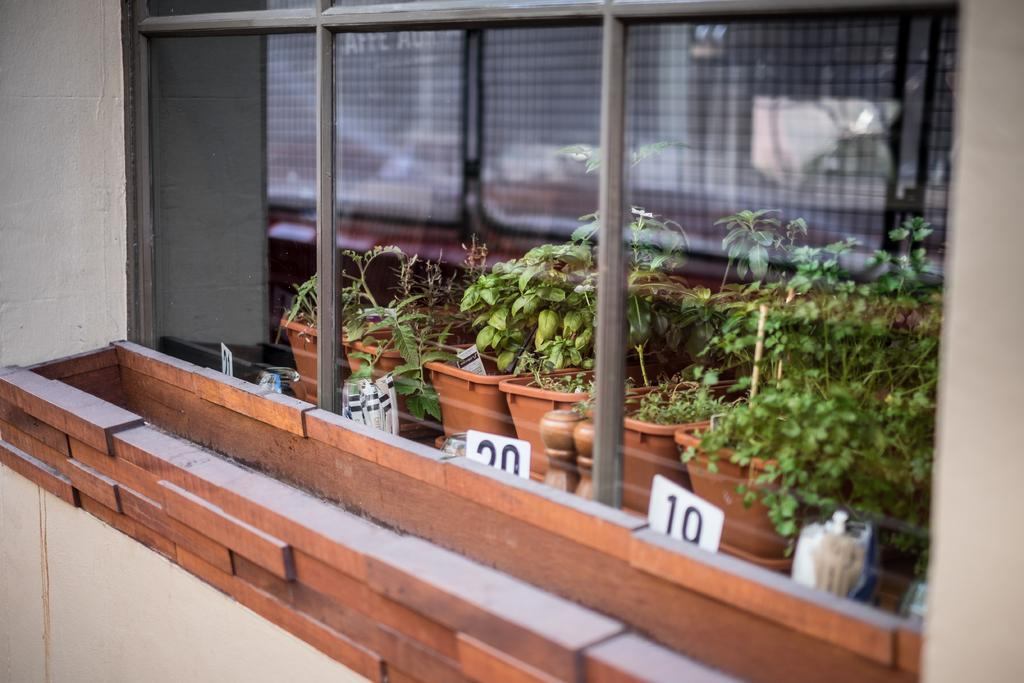What objects are present in the image that contain plants? There are flower pots in the image that contain plants. Can you describe the plants in the image? The plants in the image are not specified, but they are present in the flower pots. What type of material can be seen supporting the flower pots? Metal rods are visible in the image, supporting the flower pots. What is the level of pollution in the image? There is no information about pollution in the image, as it only features flower pots, plants, and metal rods. 